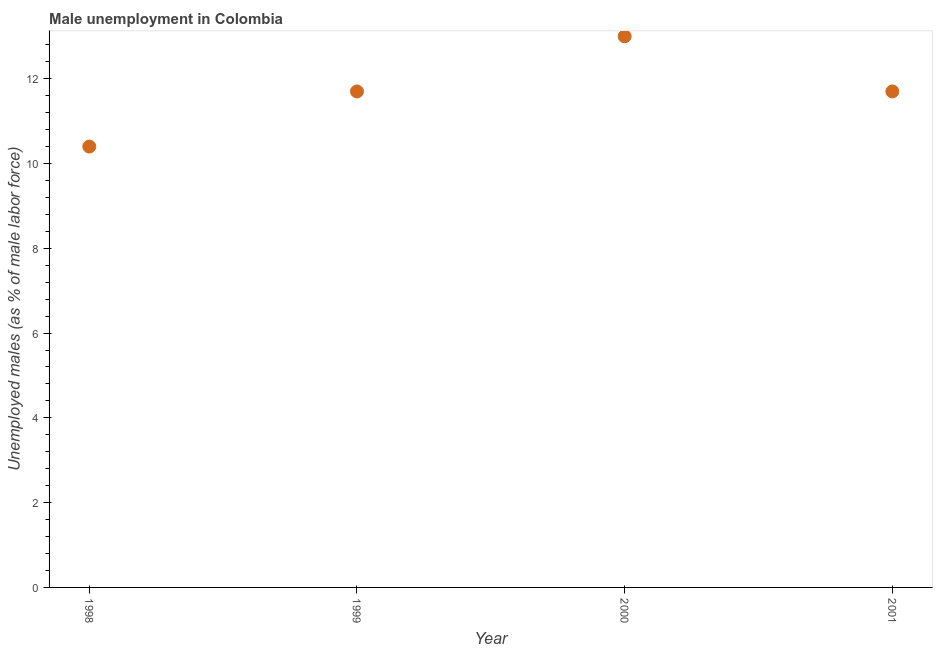What is the unemployed males population in 2001?
Offer a terse response. 11.7. Across all years, what is the minimum unemployed males population?
Your answer should be very brief. 10.4. What is the sum of the unemployed males population?
Make the answer very short. 46.8. What is the difference between the unemployed males population in 1998 and 2000?
Make the answer very short. -2.6. What is the average unemployed males population per year?
Keep it short and to the point. 11.7. What is the median unemployed males population?
Ensure brevity in your answer.  11.7. In how many years, is the unemployed males population greater than 2.4 %?
Your response must be concise. 4. What is the ratio of the unemployed males population in 1998 to that in 2000?
Offer a very short reply. 0.8. Is the unemployed males population in 1998 less than that in 2000?
Offer a very short reply. Yes. Is the difference between the unemployed males population in 1998 and 2000 greater than the difference between any two years?
Make the answer very short. Yes. What is the difference between the highest and the second highest unemployed males population?
Your answer should be compact. 1.3. What is the difference between the highest and the lowest unemployed males population?
Make the answer very short. 2.6. How many years are there in the graph?
Make the answer very short. 4. Does the graph contain any zero values?
Your response must be concise. No. Does the graph contain grids?
Offer a very short reply. No. What is the title of the graph?
Ensure brevity in your answer.  Male unemployment in Colombia. What is the label or title of the X-axis?
Your answer should be compact. Year. What is the label or title of the Y-axis?
Offer a very short reply. Unemployed males (as % of male labor force). What is the Unemployed males (as % of male labor force) in 1998?
Provide a short and direct response. 10.4. What is the Unemployed males (as % of male labor force) in 1999?
Offer a terse response. 11.7. What is the Unemployed males (as % of male labor force) in 2001?
Make the answer very short. 11.7. What is the difference between the Unemployed males (as % of male labor force) in 1998 and 1999?
Keep it short and to the point. -1.3. What is the difference between the Unemployed males (as % of male labor force) in 1998 and 2000?
Your answer should be very brief. -2.6. What is the difference between the Unemployed males (as % of male labor force) in 2000 and 2001?
Provide a succinct answer. 1.3. What is the ratio of the Unemployed males (as % of male labor force) in 1998 to that in 1999?
Your response must be concise. 0.89. What is the ratio of the Unemployed males (as % of male labor force) in 1998 to that in 2000?
Your answer should be very brief. 0.8. What is the ratio of the Unemployed males (as % of male labor force) in 1998 to that in 2001?
Provide a succinct answer. 0.89. What is the ratio of the Unemployed males (as % of male labor force) in 1999 to that in 2000?
Your response must be concise. 0.9. What is the ratio of the Unemployed males (as % of male labor force) in 2000 to that in 2001?
Your answer should be very brief. 1.11. 